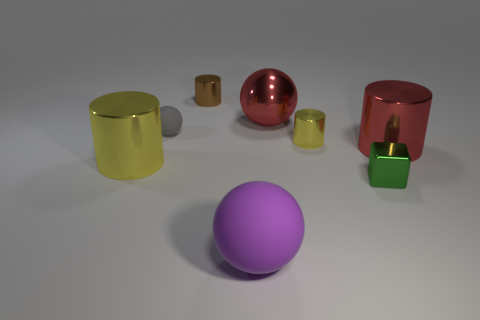Is the material of the tiny brown cylinder the same as the tiny gray object?
Offer a terse response. No. Are there any purple matte things of the same size as the green shiny object?
Provide a short and direct response. No. What is the material of the red sphere that is the same size as the red cylinder?
Offer a very short reply. Metal. Is there another purple matte thing that has the same shape as the large rubber object?
Provide a short and direct response. No. What is the material of the big thing that is the same color as the metal sphere?
Give a very brief answer. Metal. The tiny thing behind the gray rubber ball has what shape?
Your response must be concise. Cylinder. How many brown cylinders are there?
Offer a very short reply. 1. There is a big ball that is the same material as the green object; what is its color?
Ensure brevity in your answer.  Red. What number of small objects are either gray things or brown metal balls?
Offer a very short reply. 1. There is a large red shiny cylinder; what number of small green metal objects are on the right side of it?
Provide a succinct answer. 0. 